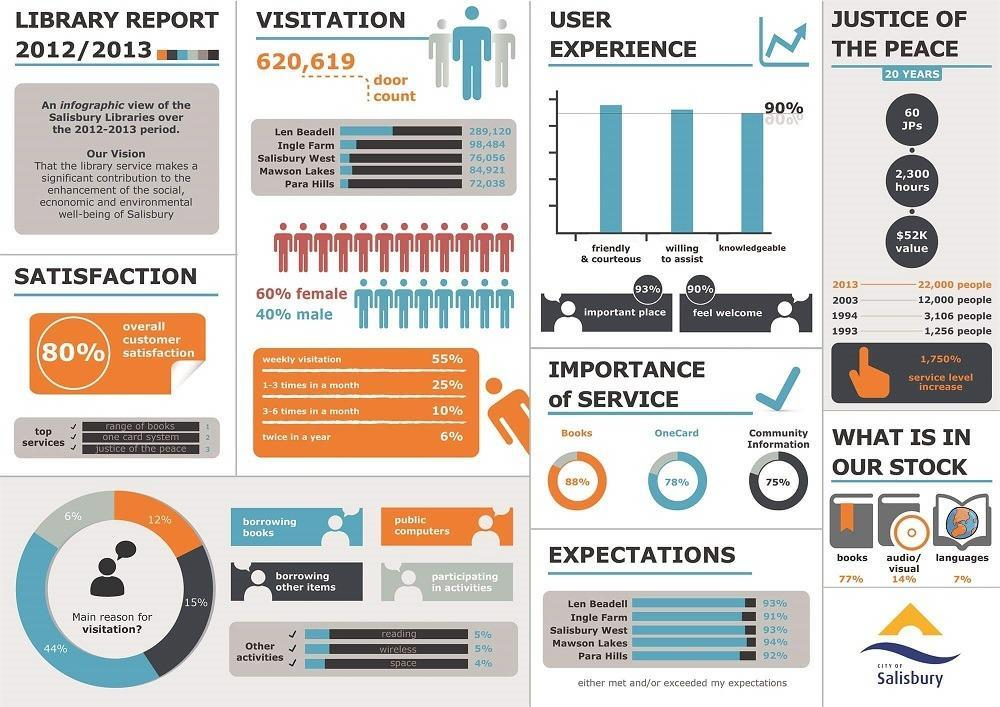What is the main reason for visitation-borrowing other items, borrowing books?
Answer the question with a short phrase. borrowing books What percentage of customers are not satisfied? 20% What is the percentage of books and languages in stock? 84% 